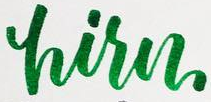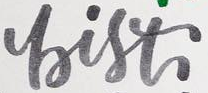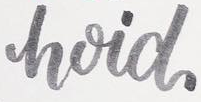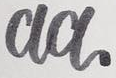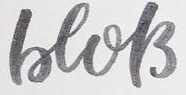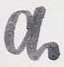What text appears in these images from left to right, separated by a semicolon? hisn; bist; hoid; aa; beols; a 